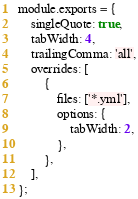Convert code to text. <code><loc_0><loc_0><loc_500><loc_500><_JavaScript_>module.exports = {
    singleQuote: true,
    tabWidth: 4,
    trailingComma: 'all',
    overrides: [
        {
            files: ['*.yml'],
            options: {
                tabWidth: 2,
            },
        },
    ],
};</code> 